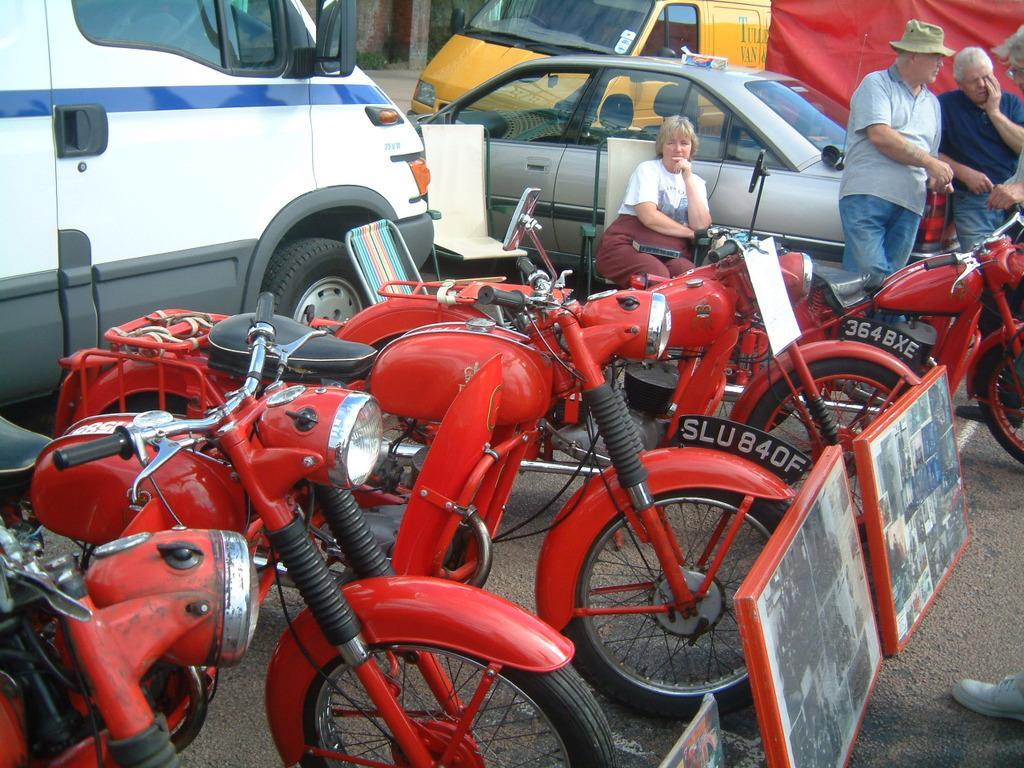How would you summarize this image in a sentence or two? This picture shows few red color motorcycles and a car and couple of vans and we see a woman seated on the chair and we see few men standing and a man wore cap on his head and few photo frames on the ground and we see couple of empty chairs. 